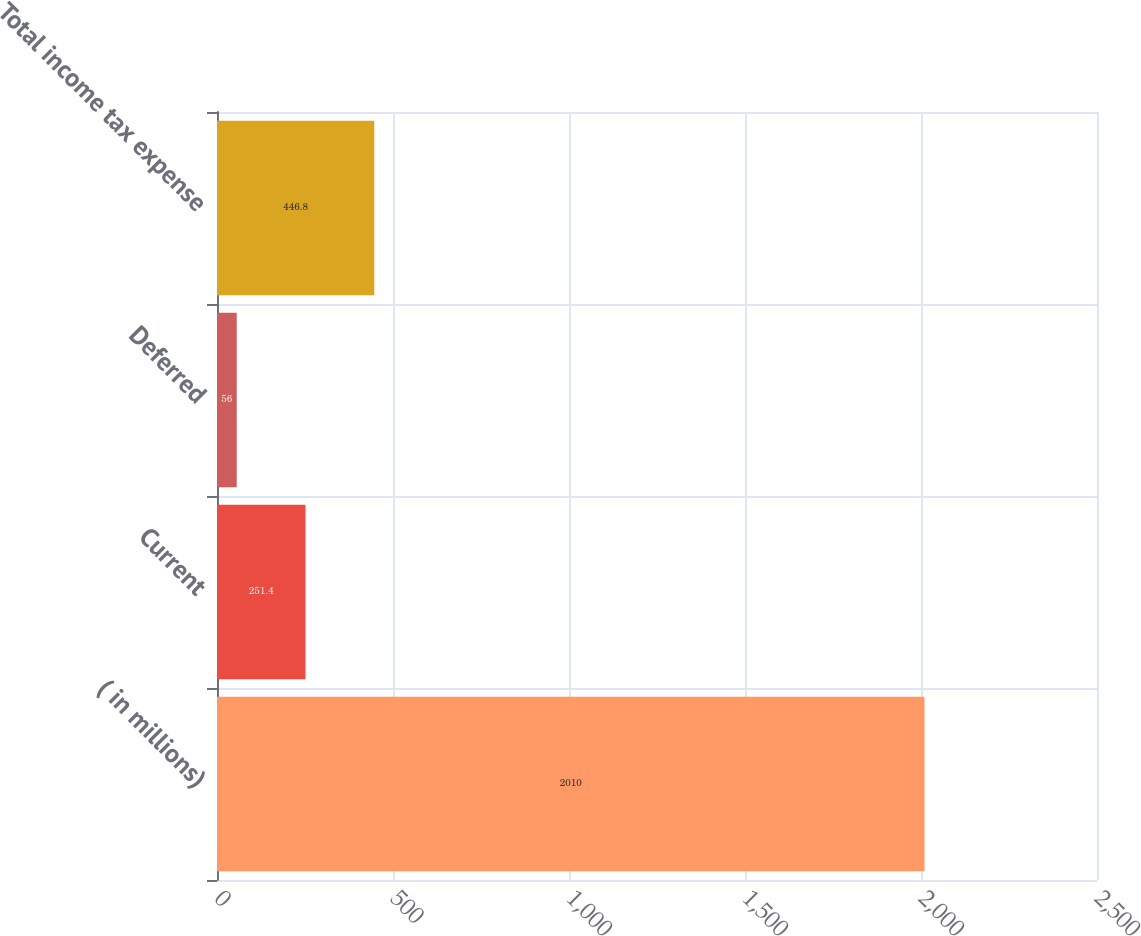Convert chart. <chart><loc_0><loc_0><loc_500><loc_500><bar_chart><fcel>( in millions)<fcel>Current<fcel>Deferred<fcel>Total income tax expense<nl><fcel>2010<fcel>251.4<fcel>56<fcel>446.8<nl></chart> 